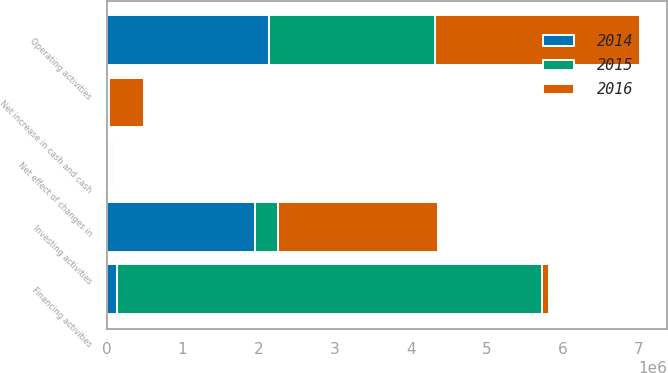<chart> <loc_0><loc_0><loc_500><loc_500><stacked_bar_chart><ecel><fcel>Operating activities<fcel>Investing activities<fcel>Financing activities<fcel>Net effect of changes in<fcel>Net increase in cash and cash<nl><fcel>2016<fcel>2.7036e+06<fcel>2.10745e+06<fcel>99294<fcel>30389<fcel>466475<nl><fcel>2015<fcel>2.18305e+06<fcel>300533<fcel>5.5891e+06<fcel>23224<fcel>7194<nl><fcel>2014<fcel>2.13459e+06<fcel>1.94955e+06<fcel>134591<fcel>30534<fcel>19916<nl></chart> 